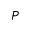<formula> <loc_0><loc_0><loc_500><loc_500>P</formula> 